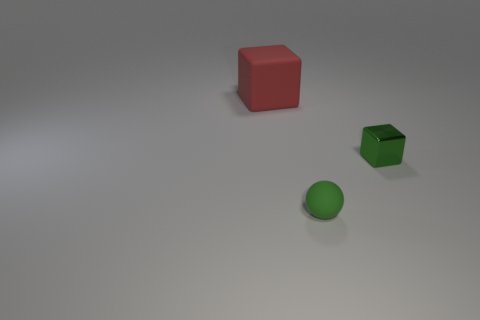How many other shiny cubes are the same color as the metal cube?
Give a very brief answer. 0. Do the small matte thing and the tiny metal thing have the same shape?
Provide a succinct answer. No. There is a green object that is right of the tiny green object that is in front of the green metallic thing; how big is it?
Your answer should be very brief. Small. Are there any other red objects that have the same size as the metallic thing?
Provide a short and direct response. No. There is a cube in front of the red object; does it have the same size as the object to the left of the tiny green rubber object?
Ensure brevity in your answer.  No. There is a rubber thing that is right of the cube on the left side of the green metal cube; what shape is it?
Your response must be concise. Sphere. How many rubber objects are behind the shiny thing?
Make the answer very short. 1. There is a thing that is the same material as the large cube; what is its color?
Offer a very short reply. Green. There is a matte cube; is it the same size as the green thing on the left side of the small metallic thing?
Give a very brief answer. No. What size is the ball that is left of the small green object right of the small green object that is to the left of the tiny green metallic object?
Your response must be concise. Small. 